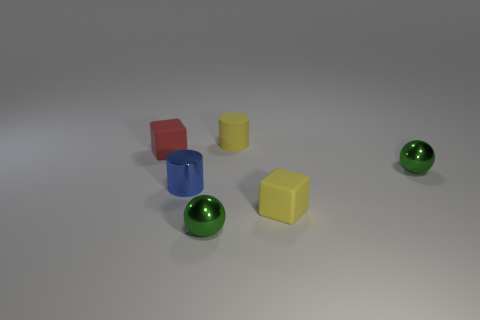How many tiny yellow cubes are to the right of the tiny green object that is behind the tiny yellow object that is in front of the tiny red cube?
Ensure brevity in your answer.  0. The thing that is both in front of the blue object and to the left of the yellow cylinder is made of what material?
Ensure brevity in your answer.  Metal. There is a object that is behind the tiny blue thing and in front of the red rubber object; what color is it?
Give a very brief answer. Green. Are there any other things that are the same color as the matte cylinder?
Keep it short and to the point. Yes. There is a yellow matte object behind the cube behind the metallic object that is to the right of the yellow cylinder; what shape is it?
Offer a terse response. Cylinder. There is another tiny thing that is the same shape as the small red thing; what color is it?
Offer a very short reply. Yellow. What is the color of the rubber cube right of the cylinder that is left of the tiny yellow cylinder?
Provide a succinct answer. Yellow. There is a yellow matte thing that is the same shape as the small blue object; what size is it?
Offer a very short reply. Small. What number of small green balls are the same material as the blue object?
Ensure brevity in your answer.  2. How many small things are to the right of the small sphere that is in front of the blue metal object?
Offer a terse response. 3. 